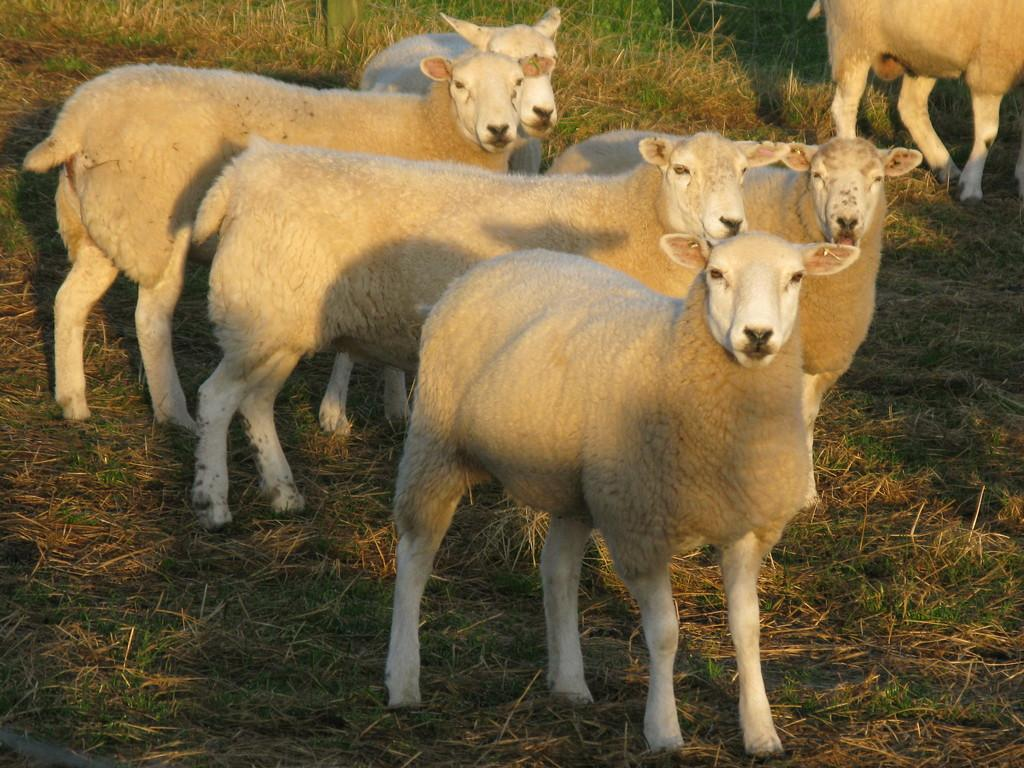What types of living organisms can be seen in the image? There are animals in the image. What is the ground covered with in the image? There is grass on the ground in the image. Can you tell me how many flowers are in the middle of the image? There are no flowers present in the image. What type of receipt can be seen in the image? There is no receipt present in the image. 